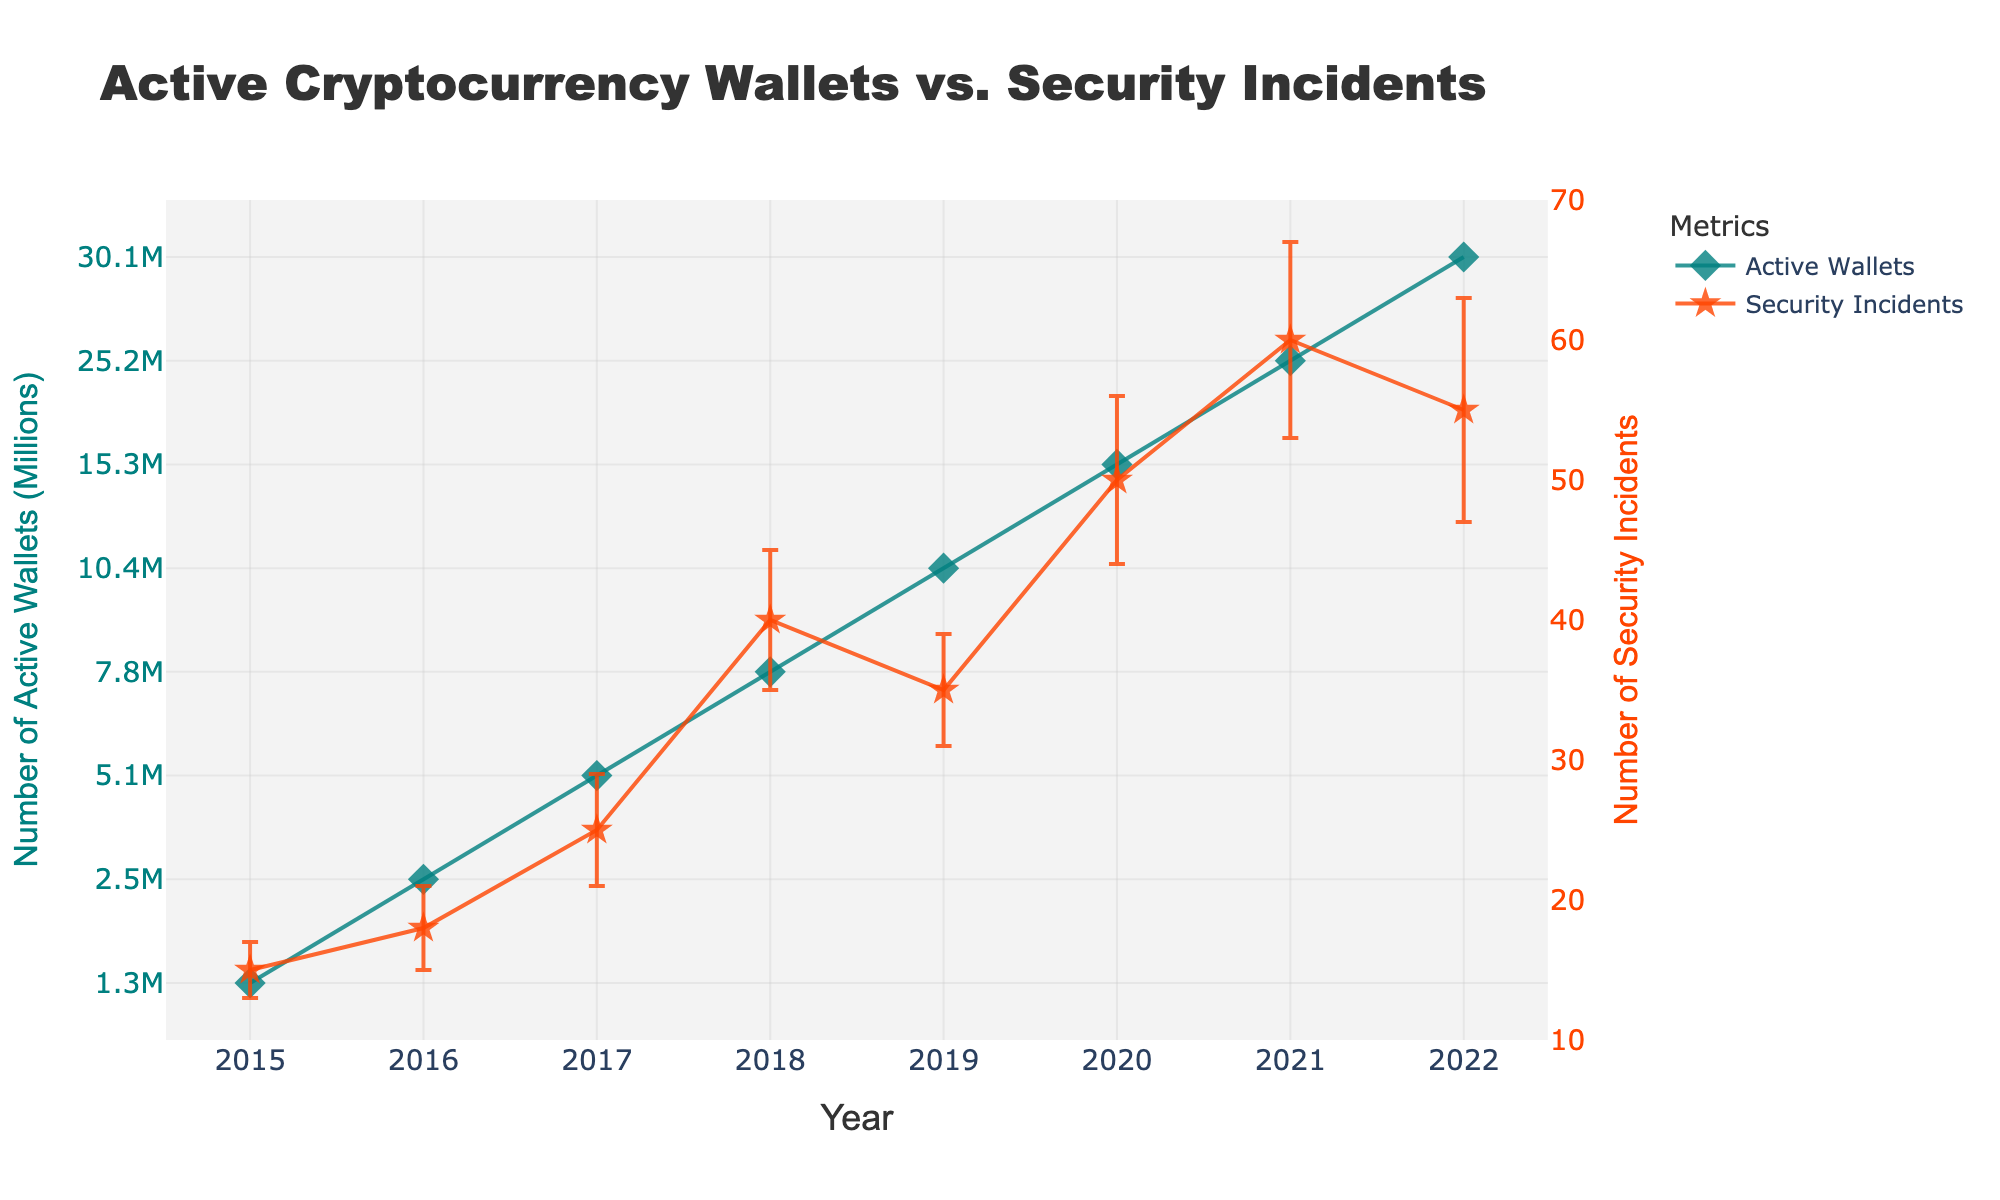What is the title of the plot? The title of the plot is located at the top of the figure.
Answer: Active Cryptocurrency Wallets vs. Security Incidents What are the units for the y-axis showing Active Wallets? The y-axis label for Active Wallets reads "Number of Active Wallets (Millions)," indicating the y-axis measures in millions.
Answer: Millions Which year had the highest number of security incidents? The data points and y-axis show the highest number of security incidents occur in 2021, at around 60 incidents.
Answer: 2021 How many more active wallets were there in 2022 compared to 2016? Subtract the number of active wallets in 2016 (2.5M) from the number in 2022 (30.1M) to find the difference. 30.1M - 2.5M = 27.6M
Answer: 27.6M What is the general trend in the number of active wallets over time? Observing the scatter plot, the number of active wallets increases steadily each year from 2015 to 2022.
Answer: Increasing trend In which year did the number of security incidents decrease compared to the previous year? By looking at the plot, the number of security incidents decreased from 2021 (60) to 2022 (55).
Answer: 2022 Which year had the largest error margin for active wallets, and what is the value? The error bars show 2022 has the largest error margin of 1.0M for active wallets.
Answer: 2022, 1.0M Compare the error margins of security incidents in 2019 and 2021. Which is larger? The plot indicates the error margin in 2019 is 4, while in 2021, it is 7. Therefore, 2021 has a larger error margin.
Answer: 2021 What are the two key metrics represented in the legend? The legend identifies the two key metrics plotted: "Active Wallets" and "Security Incidents."
Answer: Active Wallets, Security Incidents What can you infer about the relationship between the number of active wallets and security incidents from 2015 to 2021? The plot shows that as the number of active wallets increases yearly from 2015 to 2021, the number of security incidents also generally increases, suggesting a positive correlation.
Answer: Positive correlation 